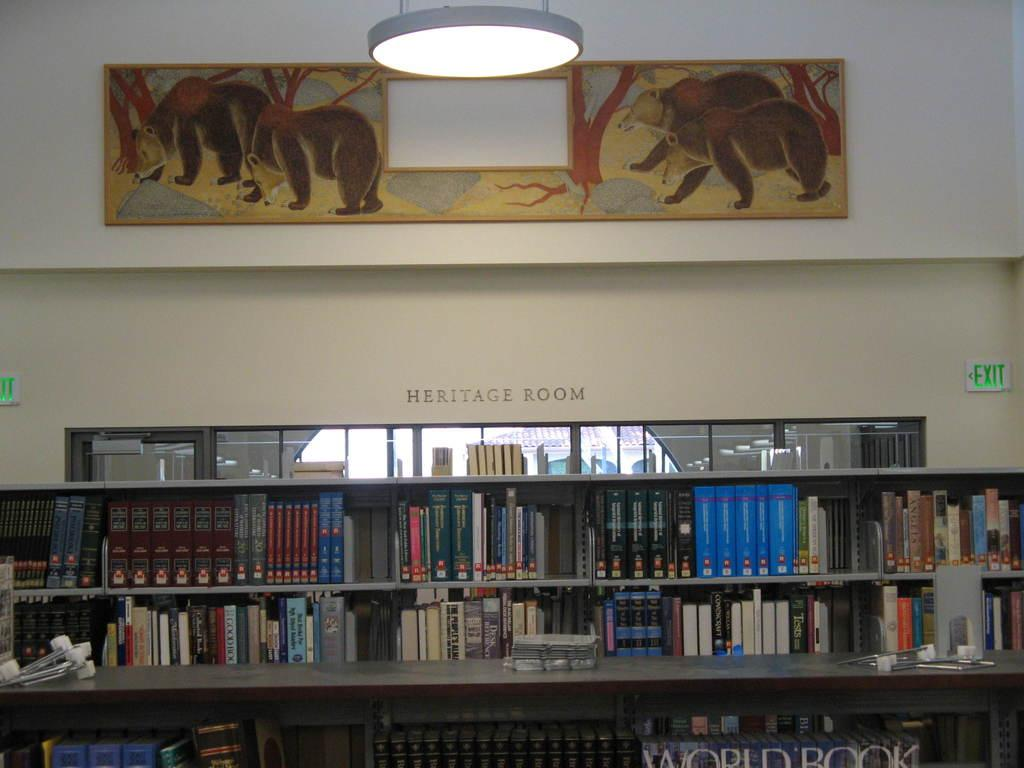<image>
Offer a succinct explanation of the picture presented. Book case full of books with the words Heritage Room on top. 